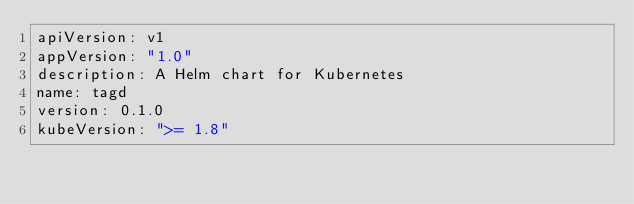Convert code to text. <code><loc_0><loc_0><loc_500><loc_500><_YAML_>apiVersion: v1
appVersion: "1.0"
description: A Helm chart for Kubernetes
name: tagd
version: 0.1.0
kubeVersion: ">= 1.8"
</code> 